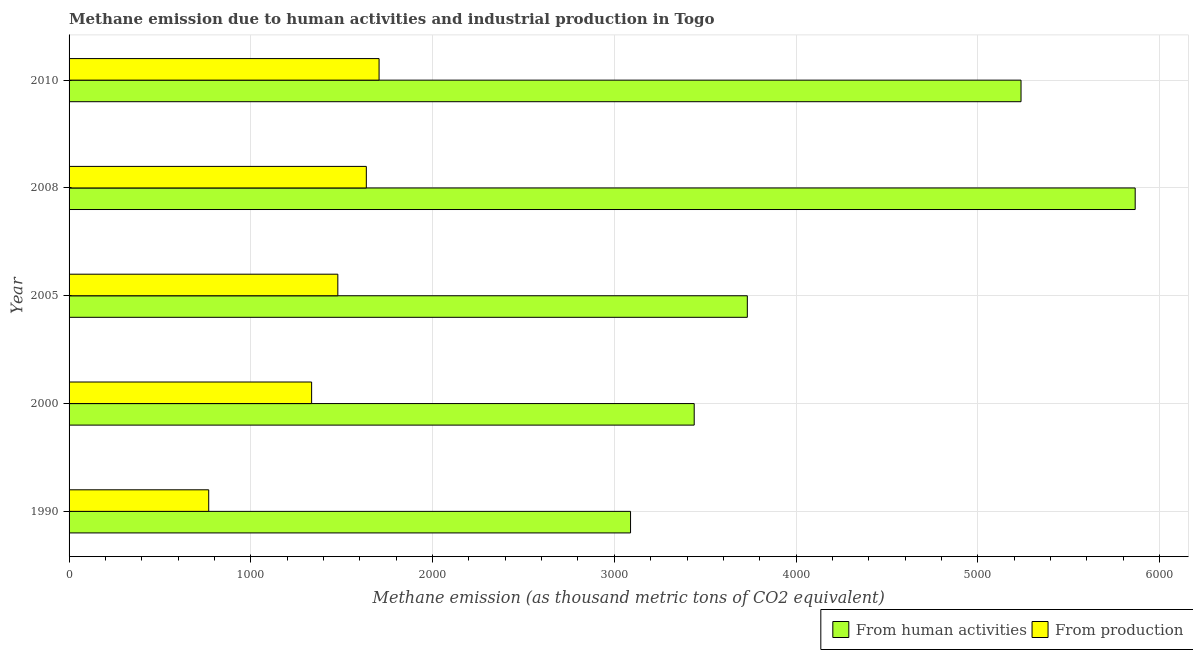How many different coloured bars are there?
Ensure brevity in your answer.  2. Are the number of bars per tick equal to the number of legend labels?
Make the answer very short. Yes. How many bars are there on the 5th tick from the bottom?
Your answer should be very brief. 2. In how many cases, is the number of bars for a given year not equal to the number of legend labels?
Your answer should be compact. 0. What is the amount of emissions generated from industries in 2008?
Your answer should be very brief. 1635.6. Across all years, what is the maximum amount of emissions generated from industries?
Your response must be concise. 1705.7. Across all years, what is the minimum amount of emissions from human activities?
Make the answer very short. 3089.4. What is the total amount of emissions from human activities in the graph?
Keep it short and to the point. 2.14e+04. What is the difference between the amount of emissions generated from industries in 2000 and that in 2010?
Provide a short and direct response. -371.1. What is the difference between the amount of emissions generated from industries in 2000 and the amount of emissions from human activities in 2010?
Your answer should be compact. -3903.3. What is the average amount of emissions from human activities per year?
Give a very brief answer. 4272.96. In the year 2000, what is the difference between the amount of emissions from human activities and amount of emissions generated from industries?
Ensure brevity in your answer.  2105. In how many years, is the amount of emissions generated from industries greater than 4000 thousand metric tons?
Provide a short and direct response. 0. What is the ratio of the amount of emissions generated from industries in 1990 to that in 2000?
Ensure brevity in your answer.  0.58. What is the difference between the highest and the second highest amount of emissions generated from industries?
Offer a very short reply. 70.1. What is the difference between the highest and the lowest amount of emissions generated from industries?
Provide a short and direct response. 937.3. In how many years, is the amount of emissions from human activities greater than the average amount of emissions from human activities taken over all years?
Provide a succinct answer. 2. Is the sum of the amount of emissions from human activities in 2005 and 2008 greater than the maximum amount of emissions generated from industries across all years?
Your response must be concise. Yes. What does the 2nd bar from the top in 1990 represents?
Offer a very short reply. From human activities. What does the 2nd bar from the bottom in 2005 represents?
Offer a very short reply. From production. How many bars are there?
Keep it short and to the point. 10. Are all the bars in the graph horizontal?
Make the answer very short. Yes. How many years are there in the graph?
Offer a terse response. 5. What is the difference between two consecutive major ticks on the X-axis?
Offer a terse response. 1000. Are the values on the major ticks of X-axis written in scientific E-notation?
Your response must be concise. No. Where does the legend appear in the graph?
Give a very brief answer. Bottom right. How many legend labels are there?
Make the answer very short. 2. How are the legend labels stacked?
Your response must be concise. Horizontal. What is the title of the graph?
Offer a very short reply. Methane emission due to human activities and industrial production in Togo. Does "Current education expenditure" appear as one of the legend labels in the graph?
Make the answer very short. No. What is the label or title of the X-axis?
Your answer should be compact. Methane emission (as thousand metric tons of CO2 equivalent). What is the Methane emission (as thousand metric tons of CO2 equivalent) in From human activities in 1990?
Give a very brief answer. 3089.4. What is the Methane emission (as thousand metric tons of CO2 equivalent) of From production in 1990?
Offer a terse response. 768.4. What is the Methane emission (as thousand metric tons of CO2 equivalent) of From human activities in 2000?
Offer a terse response. 3439.6. What is the Methane emission (as thousand metric tons of CO2 equivalent) in From production in 2000?
Your response must be concise. 1334.6. What is the Methane emission (as thousand metric tons of CO2 equivalent) in From human activities in 2005?
Your answer should be very brief. 3731.9. What is the Methane emission (as thousand metric tons of CO2 equivalent) of From production in 2005?
Your answer should be very brief. 1478.8. What is the Methane emission (as thousand metric tons of CO2 equivalent) of From human activities in 2008?
Your answer should be very brief. 5866. What is the Methane emission (as thousand metric tons of CO2 equivalent) of From production in 2008?
Offer a terse response. 1635.6. What is the Methane emission (as thousand metric tons of CO2 equivalent) of From human activities in 2010?
Offer a very short reply. 5237.9. What is the Methane emission (as thousand metric tons of CO2 equivalent) of From production in 2010?
Offer a terse response. 1705.7. Across all years, what is the maximum Methane emission (as thousand metric tons of CO2 equivalent) of From human activities?
Keep it short and to the point. 5866. Across all years, what is the maximum Methane emission (as thousand metric tons of CO2 equivalent) in From production?
Give a very brief answer. 1705.7. Across all years, what is the minimum Methane emission (as thousand metric tons of CO2 equivalent) in From human activities?
Your response must be concise. 3089.4. Across all years, what is the minimum Methane emission (as thousand metric tons of CO2 equivalent) in From production?
Offer a very short reply. 768.4. What is the total Methane emission (as thousand metric tons of CO2 equivalent) of From human activities in the graph?
Your response must be concise. 2.14e+04. What is the total Methane emission (as thousand metric tons of CO2 equivalent) in From production in the graph?
Make the answer very short. 6923.1. What is the difference between the Methane emission (as thousand metric tons of CO2 equivalent) in From human activities in 1990 and that in 2000?
Ensure brevity in your answer.  -350.2. What is the difference between the Methane emission (as thousand metric tons of CO2 equivalent) in From production in 1990 and that in 2000?
Your answer should be compact. -566.2. What is the difference between the Methane emission (as thousand metric tons of CO2 equivalent) of From human activities in 1990 and that in 2005?
Your answer should be very brief. -642.5. What is the difference between the Methane emission (as thousand metric tons of CO2 equivalent) of From production in 1990 and that in 2005?
Provide a short and direct response. -710.4. What is the difference between the Methane emission (as thousand metric tons of CO2 equivalent) in From human activities in 1990 and that in 2008?
Your response must be concise. -2776.6. What is the difference between the Methane emission (as thousand metric tons of CO2 equivalent) of From production in 1990 and that in 2008?
Make the answer very short. -867.2. What is the difference between the Methane emission (as thousand metric tons of CO2 equivalent) in From human activities in 1990 and that in 2010?
Keep it short and to the point. -2148.5. What is the difference between the Methane emission (as thousand metric tons of CO2 equivalent) of From production in 1990 and that in 2010?
Keep it short and to the point. -937.3. What is the difference between the Methane emission (as thousand metric tons of CO2 equivalent) in From human activities in 2000 and that in 2005?
Offer a very short reply. -292.3. What is the difference between the Methane emission (as thousand metric tons of CO2 equivalent) in From production in 2000 and that in 2005?
Offer a terse response. -144.2. What is the difference between the Methane emission (as thousand metric tons of CO2 equivalent) of From human activities in 2000 and that in 2008?
Ensure brevity in your answer.  -2426.4. What is the difference between the Methane emission (as thousand metric tons of CO2 equivalent) of From production in 2000 and that in 2008?
Offer a terse response. -301. What is the difference between the Methane emission (as thousand metric tons of CO2 equivalent) in From human activities in 2000 and that in 2010?
Your response must be concise. -1798.3. What is the difference between the Methane emission (as thousand metric tons of CO2 equivalent) in From production in 2000 and that in 2010?
Keep it short and to the point. -371.1. What is the difference between the Methane emission (as thousand metric tons of CO2 equivalent) of From human activities in 2005 and that in 2008?
Your answer should be very brief. -2134.1. What is the difference between the Methane emission (as thousand metric tons of CO2 equivalent) in From production in 2005 and that in 2008?
Ensure brevity in your answer.  -156.8. What is the difference between the Methane emission (as thousand metric tons of CO2 equivalent) of From human activities in 2005 and that in 2010?
Make the answer very short. -1506. What is the difference between the Methane emission (as thousand metric tons of CO2 equivalent) of From production in 2005 and that in 2010?
Your answer should be compact. -226.9. What is the difference between the Methane emission (as thousand metric tons of CO2 equivalent) of From human activities in 2008 and that in 2010?
Your answer should be very brief. 628.1. What is the difference between the Methane emission (as thousand metric tons of CO2 equivalent) of From production in 2008 and that in 2010?
Your answer should be very brief. -70.1. What is the difference between the Methane emission (as thousand metric tons of CO2 equivalent) in From human activities in 1990 and the Methane emission (as thousand metric tons of CO2 equivalent) in From production in 2000?
Your response must be concise. 1754.8. What is the difference between the Methane emission (as thousand metric tons of CO2 equivalent) of From human activities in 1990 and the Methane emission (as thousand metric tons of CO2 equivalent) of From production in 2005?
Provide a short and direct response. 1610.6. What is the difference between the Methane emission (as thousand metric tons of CO2 equivalent) in From human activities in 1990 and the Methane emission (as thousand metric tons of CO2 equivalent) in From production in 2008?
Your answer should be very brief. 1453.8. What is the difference between the Methane emission (as thousand metric tons of CO2 equivalent) of From human activities in 1990 and the Methane emission (as thousand metric tons of CO2 equivalent) of From production in 2010?
Keep it short and to the point. 1383.7. What is the difference between the Methane emission (as thousand metric tons of CO2 equivalent) of From human activities in 2000 and the Methane emission (as thousand metric tons of CO2 equivalent) of From production in 2005?
Your answer should be compact. 1960.8. What is the difference between the Methane emission (as thousand metric tons of CO2 equivalent) of From human activities in 2000 and the Methane emission (as thousand metric tons of CO2 equivalent) of From production in 2008?
Provide a succinct answer. 1804. What is the difference between the Methane emission (as thousand metric tons of CO2 equivalent) in From human activities in 2000 and the Methane emission (as thousand metric tons of CO2 equivalent) in From production in 2010?
Ensure brevity in your answer.  1733.9. What is the difference between the Methane emission (as thousand metric tons of CO2 equivalent) in From human activities in 2005 and the Methane emission (as thousand metric tons of CO2 equivalent) in From production in 2008?
Your response must be concise. 2096.3. What is the difference between the Methane emission (as thousand metric tons of CO2 equivalent) of From human activities in 2005 and the Methane emission (as thousand metric tons of CO2 equivalent) of From production in 2010?
Your response must be concise. 2026.2. What is the difference between the Methane emission (as thousand metric tons of CO2 equivalent) in From human activities in 2008 and the Methane emission (as thousand metric tons of CO2 equivalent) in From production in 2010?
Offer a very short reply. 4160.3. What is the average Methane emission (as thousand metric tons of CO2 equivalent) of From human activities per year?
Your answer should be compact. 4272.96. What is the average Methane emission (as thousand metric tons of CO2 equivalent) of From production per year?
Make the answer very short. 1384.62. In the year 1990, what is the difference between the Methane emission (as thousand metric tons of CO2 equivalent) in From human activities and Methane emission (as thousand metric tons of CO2 equivalent) in From production?
Provide a short and direct response. 2321. In the year 2000, what is the difference between the Methane emission (as thousand metric tons of CO2 equivalent) of From human activities and Methane emission (as thousand metric tons of CO2 equivalent) of From production?
Make the answer very short. 2105. In the year 2005, what is the difference between the Methane emission (as thousand metric tons of CO2 equivalent) of From human activities and Methane emission (as thousand metric tons of CO2 equivalent) of From production?
Provide a short and direct response. 2253.1. In the year 2008, what is the difference between the Methane emission (as thousand metric tons of CO2 equivalent) in From human activities and Methane emission (as thousand metric tons of CO2 equivalent) in From production?
Provide a succinct answer. 4230.4. In the year 2010, what is the difference between the Methane emission (as thousand metric tons of CO2 equivalent) of From human activities and Methane emission (as thousand metric tons of CO2 equivalent) of From production?
Ensure brevity in your answer.  3532.2. What is the ratio of the Methane emission (as thousand metric tons of CO2 equivalent) of From human activities in 1990 to that in 2000?
Provide a succinct answer. 0.9. What is the ratio of the Methane emission (as thousand metric tons of CO2 equivalent) in From production in 1990 to that in 2000?
Provide a short and direct response. 0.58. What is the ratio of the Methane emission (as thousand metric tons of CO2 equivalent) in From human activities in 1990 to that in 2005?
Provide a succinct answer. 0.83. What is the ratio of the Methane emission (as thousand metric tons of CO2 equivalent) of From production in 1990 to that in 2005?
Give a very brief answer. 0.52. What is the ratio of the Methane emission (as thousand metric tons of CO2 equivalent) in From human activities in 1990 to that in 2008?
Provide a short and direct response. 0.53. What is the ratio of the Methane emission (as thousand metric tons of CO2 equivalent) in From production in 1990 to that in 2008?
Ensure brevity in your answer.  0.47. What is the ratio of the Methane emission (as thousand metric tons of CO2 equivalent) in From human activities in 1990 to that in 2010?
Ensure brevity in your answer.  0.59. What is the ratio of the Methane emission (as thousand metric tons of CO2 equivalent) of From production in 1990 to that in 2010?
Make the answer very short. 0.45. What is the ratio of the Methane emission (as thousand metric tons of CO2 equivalent) of From human activities in 2000 to that in 2005?
Your answer should be very brief. 0.92. What is the ratio of the Methane emission (as thousand metric tons of CO2 equivalent) in From production in 2000 to that in 2005?
Your response must be concise. 0.9. What is the ratio of the Methane emission (as thousand metric tons of CO2 equivalent) of From human activities in 2000 to that in 2008?
Your answer should be very brief. 0.59. What is the ratio of the Methane emission (as thousand metric tons of CO2 equivalent) of From production in 2000 to that in 2008?
Your answer should be compact. 0.82. What is the ratio of the Methane emission (as thousand metric tons of CO2 equivalent) of From human activities in 2000 to that in 2010?
Make the answer very short. 0.66. What is the ratio of the Methane emission (as thousand metric tons of CO2 equivalent) of From production in 2000 to that in 2010?
Make the answer very short. 0.78. What is the ratio of the Methane emission (as thousand metric tons of CO2 equivalent) in From human activities in 2005 to that in 2008?
Offer a very short reply. 0.64. What is the ratio of the Methane emission (as thousand metric tons of CO2 equivalent) of From production in 2005 to that in 2008?
Make the answer very short. 0.9. What is the ratio of the Methane emission (as thousand metric tons of CO2 equivalent) in From human activities in 2005 to that in 2010?
Your response must be concise. 0.71. What is the ratio of the Methane emission (as thousand metric tons of CO2 equivalent) of From production in 2005 to that in 2010?
Offer a terse response. 0.87. What is the ratio of the Methane emission (as thousand metric tons of CO2 equivalent) in From human activities in 2008 to that in 2010?
Provide a succinct answer. 1.12. What is the ratio of the Methane emission (as thousand metric tons of CO2 equivalent) in From production in 2008 to that in 2010?
Your answer should be compact. 0.96. What is the difference between the highest and the second highest Methane emission (as thousand metric tons of CO2 equivalent) in From human activities?
Your response must be concise. 628.1. What is the difference between the highest and the second highest Methane emission (as thousand metric tons of CO2 equivalent) in From production?
Offer a very short reply. 70.1. What is the difference between the highest and the lowest Methane emission (as thousand metric tons of CO2 equivalent) in From human activities?
Your answer should be compact. 2776.6. What is the difference between the highest and the lowest Methane emission (as thousand metric tons of CO2 equivalent) in From production?
Keep it short and to the point. 937.3. 